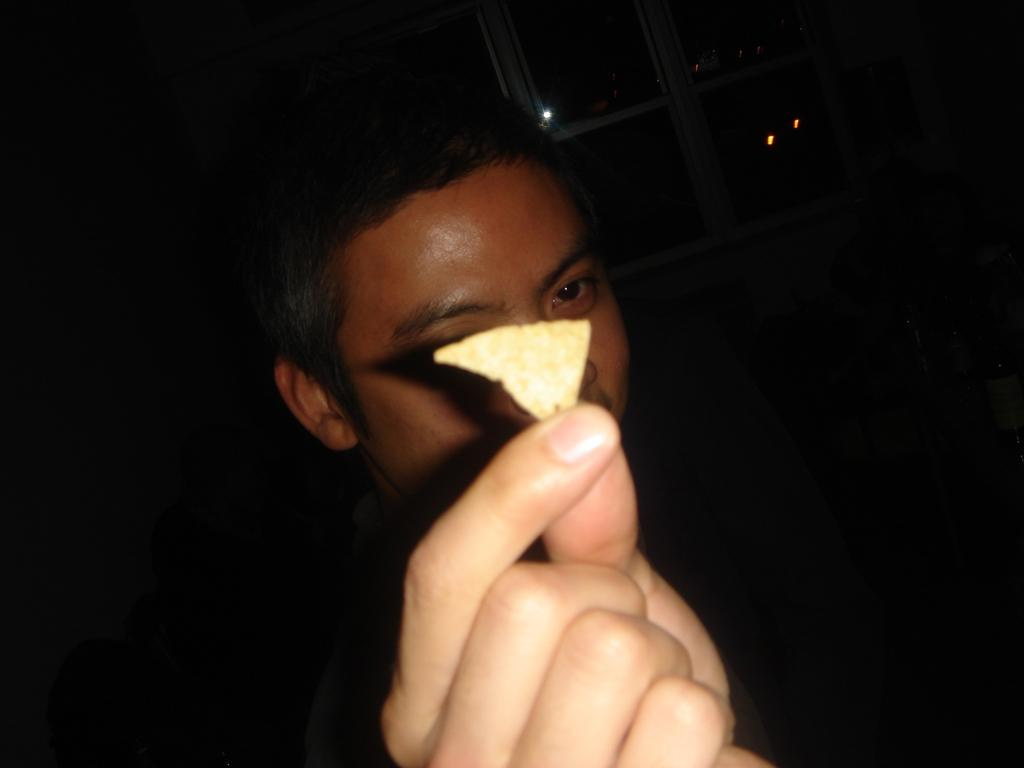What is the main subject of the image? There is a person in the image. What is the person holding in their hand? The person is holding an object in their hand. Can you describe the background of the image? The background of the image is dark. What type of maid can be seen cleaning the hall in the image? There is no maid or hall present in the image; it only features a person holding an object in their hand against a dark background. 